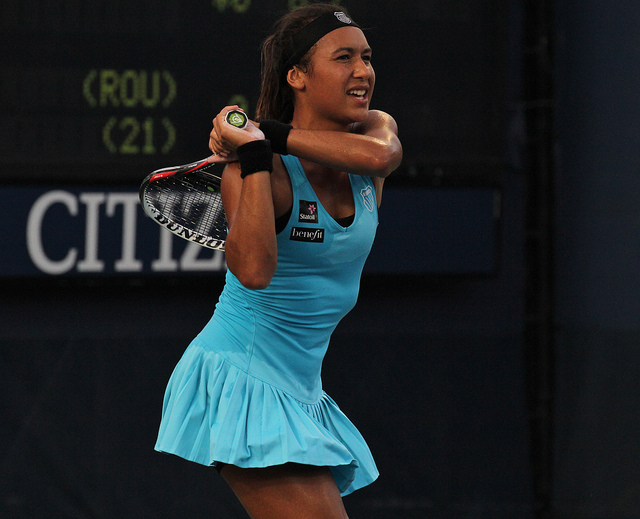Please identify all text content in this image. ROU 21 CITIZ DUNLO 